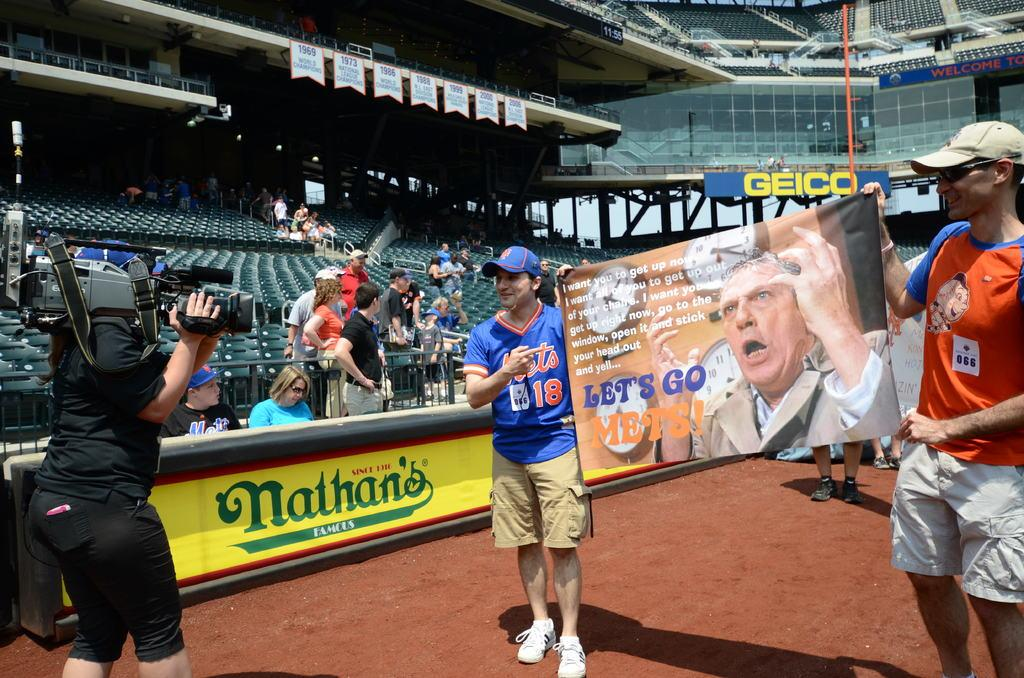<image>
Summarize the visual content of the image. Two New York Mets fans hold up a sign reading Let's go Mets! 